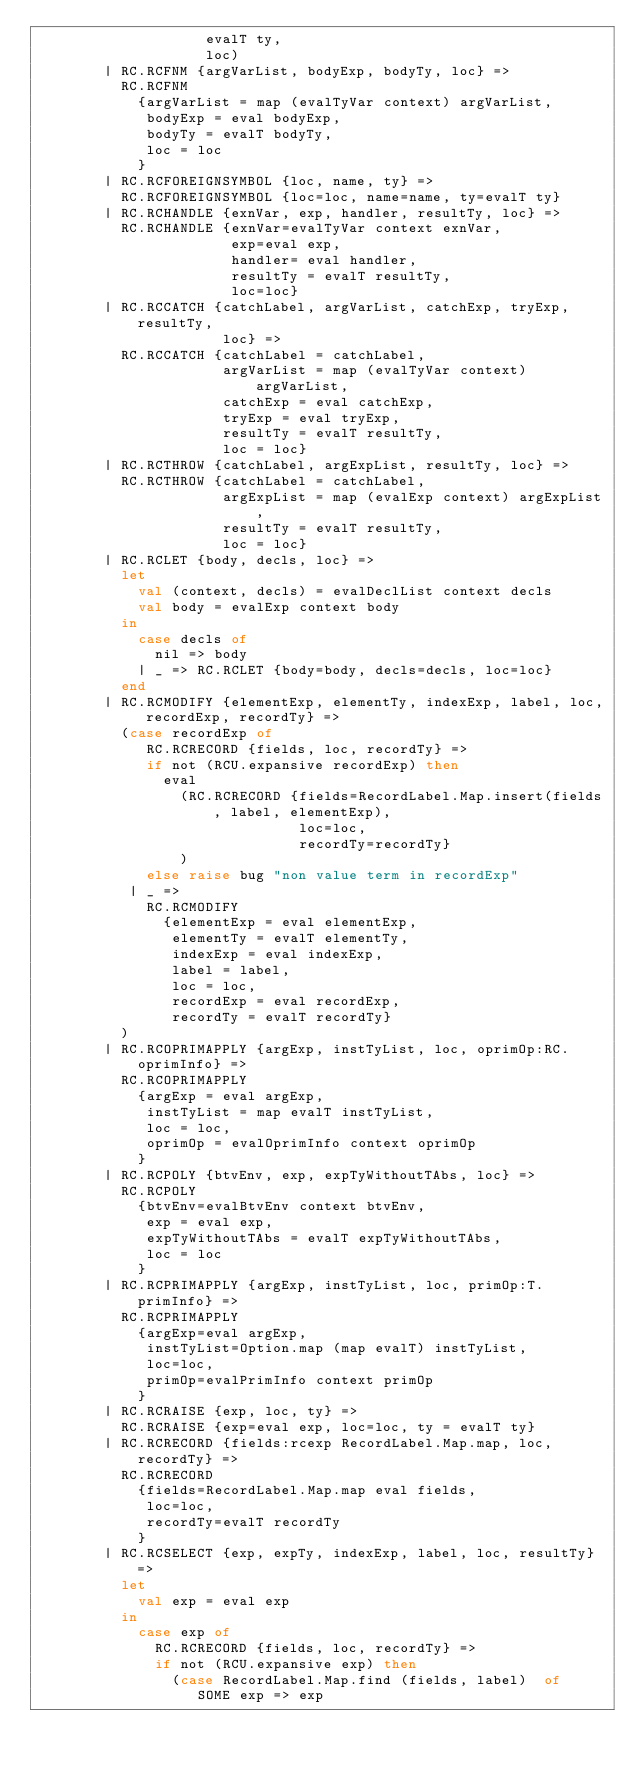Convert code to text. <code><loc_0><loc_0><loc_500><loc_500><_SML_>                    evalT ty,
                    loc)
        | RC.RCFNM {argVarList, bodyExp, bodyTy, loc} =>
          RC.RCFNM
            {argVarList = map (evalTyVar context) argVarList,
             bodyExp = eval bodyExp,
             bodyTy = evalT bodyTy,
             loc = loc
            }
        | RC.RCFOREIGNSYMBOL {loc, name, ty} =>
          RC.RCFOREIGNSYMBOL {loc=loc, name=name, ty=evalT ty}
        | RC.RCHANDLE {exnVar, exp, handler, resultTy, loc} =>
          RC.RCHANDLE {exnVar=evalTyVar context exnVar,
                       exp=eval exp,
                       handler= eval handler,
                       resultTy = evalT resultTy,
                       loc=loc}
        | RC.RCCATCH {catchLabel, argVarList, catchExp, tryExp, resultTy,
                      loc} =>
          RC.RCCATCH {catchLabel = catchLabel,
                      argVarList = map (evalTyVar context) argVarList,
                      catchExp = eval catchExp,
                      tryExp = eval tryExp,
                      resultTy = evalT resultTy,
                      loc = loc}
        | RC.RCTHROW {catchLabel, argExpList, resultTy, loc} =>
          RC.RCTHROW {catchLabel = catchLabel,
                      argExpList = map (evalExp context) argExpList,
                      resultTy = evalT resultTy,
                      loc = loc}
        | RC.RCLET {body, decls, loc} =>
          let
            val (context, decls) = evalDeclList context decls
            val body = evalExp context body
          in
            case decls of
              nil => body
            | _ => RC.RCLET {body=body, decls=decls, loc=loc}
          end
        | RC.RCMODIFY {elementExp, elementTy, indexExp, label, loc, recordExp, recordTy} =>
          (case recordExp of
             RC.RCRECORD {fields, loc, recordTy} =>
             if not (RCU.expansive recordExp) then
               eval 
                 (RC.RCRECORD {fields=RecordLabel.Map.insert(fields, label, elementExp), 
                               loc=loc, 
                               recordTy=recordTy}
                 )
             else raise bug "non value term in recordExp"
           | _ => 
             RC.RCMODIFY
               {elementExp = eval elementExp,
                elementTy = evalT elementTy,
                indexExp = eval indexExp,
                label = label,
                loc = loc,
                recordExp = eval recordExp,
                recordTy = evalT recordTy}
          )
        | RC.RCOPRIMAPPLY {argExp, instTyList, loc, oprimOp:RC.oprimInfo} =>
          RC.RCOPRIMAPPLY
            {argExp = eval argExp,
             instTyList = map evalT instTyList,
             loc = loc,
             oprimOp = evalOprimInfo context oprimOp
            }
        | RC.RCPOLY {btvEnv, exp, expTyWithoutTAbs, loc} =>
          RC.RCPOLY
            {btvEnv=evalBtvEnv context btvEnv,
             exp = eval exp,
             expTyWithoutTAbs = evalT expTyWithoutTAbs,
             loc = loc
            }
        | RC.RCPRIMAPPLY {argExp, instTyList, loc, primOp:T.primInfo} =>
          RC.RCPRIMAPPLY
            {argExp=eval argExp,
             instTyList=Option.map (map evalT) instTyList,
             loc=loc,
             primOp=evalPrimInfo context primOp
            }
        | RC.RCRAISE {exp, loc, ty} =>
          RC.RCRAISE {exp=eval exp, loc=loc, ty = evalT ty}
        | RC.RCRECORD {fields:rcexp RecordLabel.Map.map, loc, recordTy} =>
          RC.RCRECORD
            {fields=RecordLabel.Map.map eval fields,
             loc=loc,
             recordTy=evalT recordTy
            }
        | RC.RCSELECT {exp, expTy, indexExp, label, loc, resultTy} =>
          let
            val exp = eval exp
          in
            case exp of
              RC.RCRECORD {fields, loc, recordTy} =>
              if not (RCU.expansive exp) then
                (case RecordLabel.Map.find (fields, label)  of
                   SOME exp => exp</code> 